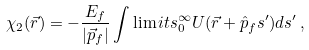<formula> <loc_0><loc_0><loc_500><loc_500>\chi _ { 2 } ( \vec { r } ) = - \frac { E _ { f } } { | \vec { p } _ { f } | } \int \lim i t s _ { 0 } ^ { \infty } U ( \vec { r } + \hat { p } _ { f } s ^ { \prime } ) d s ^ { \prime } \, ,</formula> 